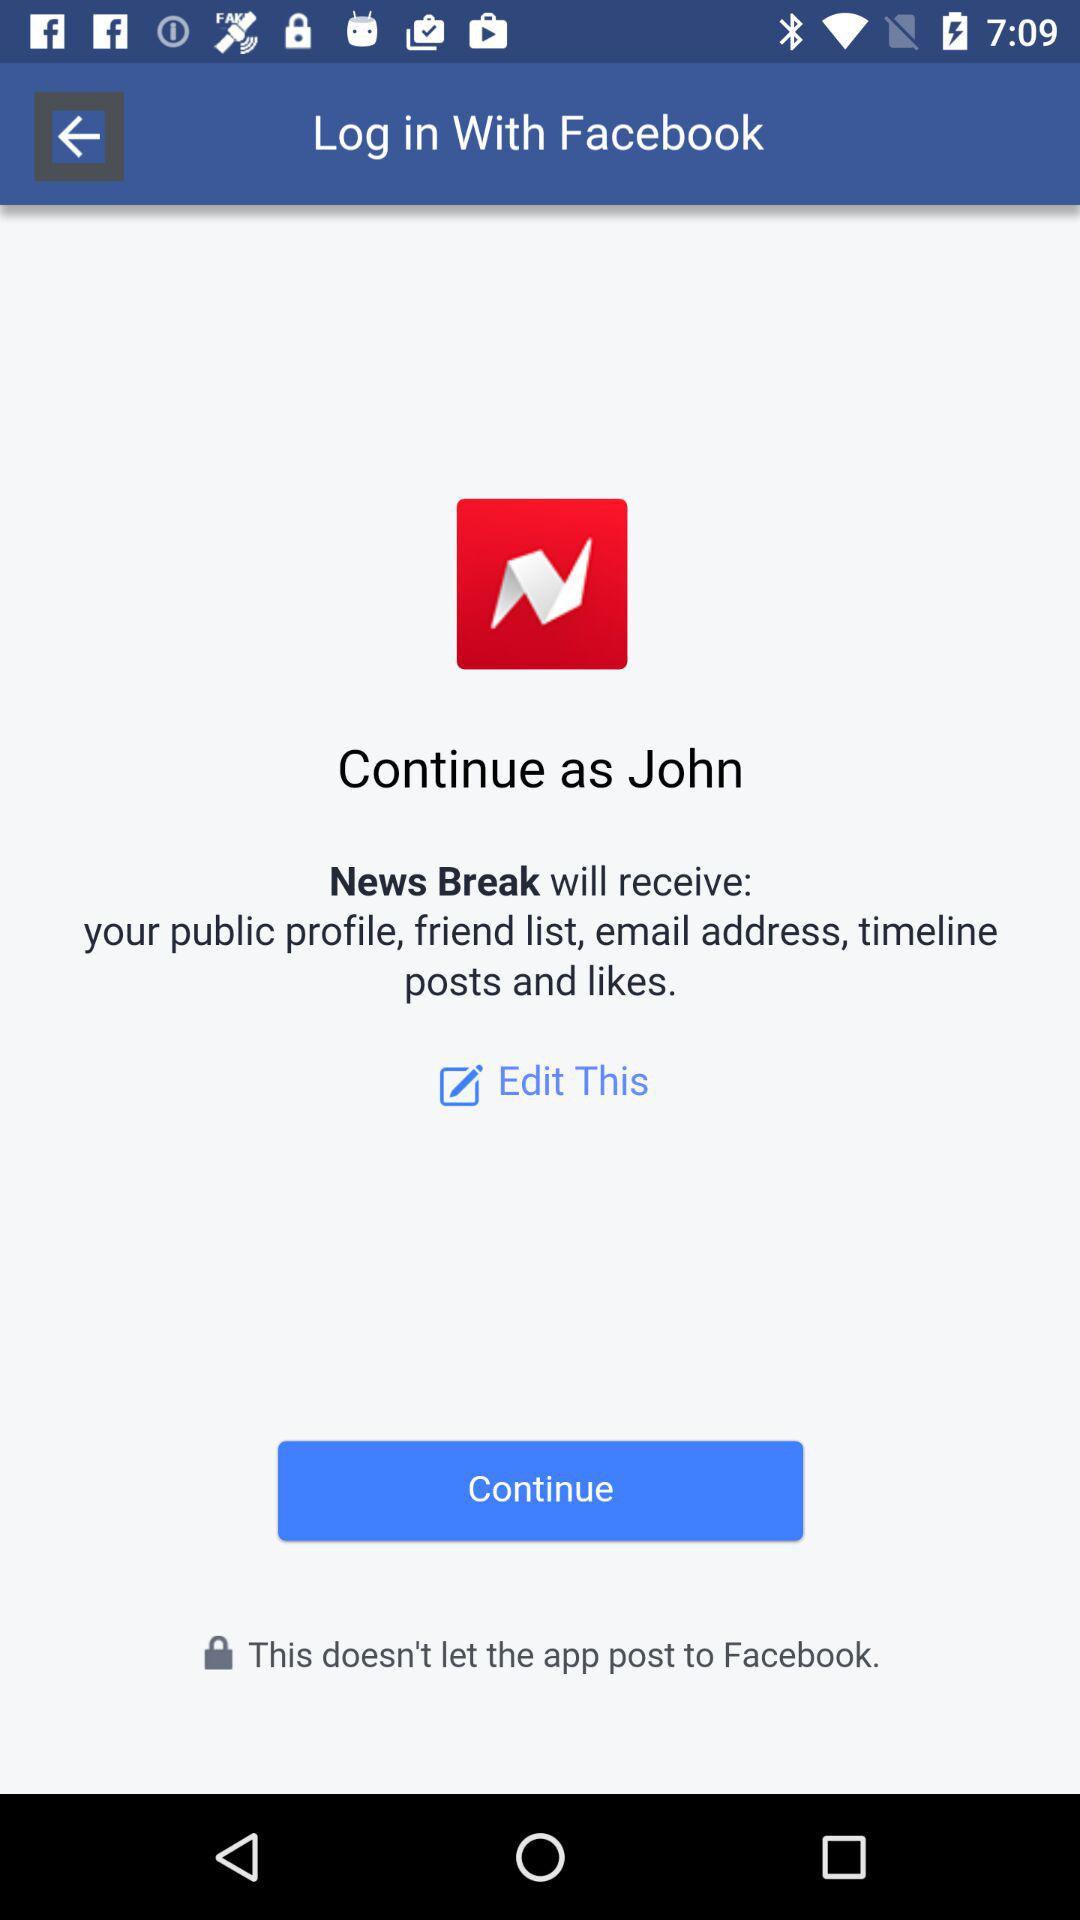Who will receive a public profile? The application that will receive a public profile is "News Break". 